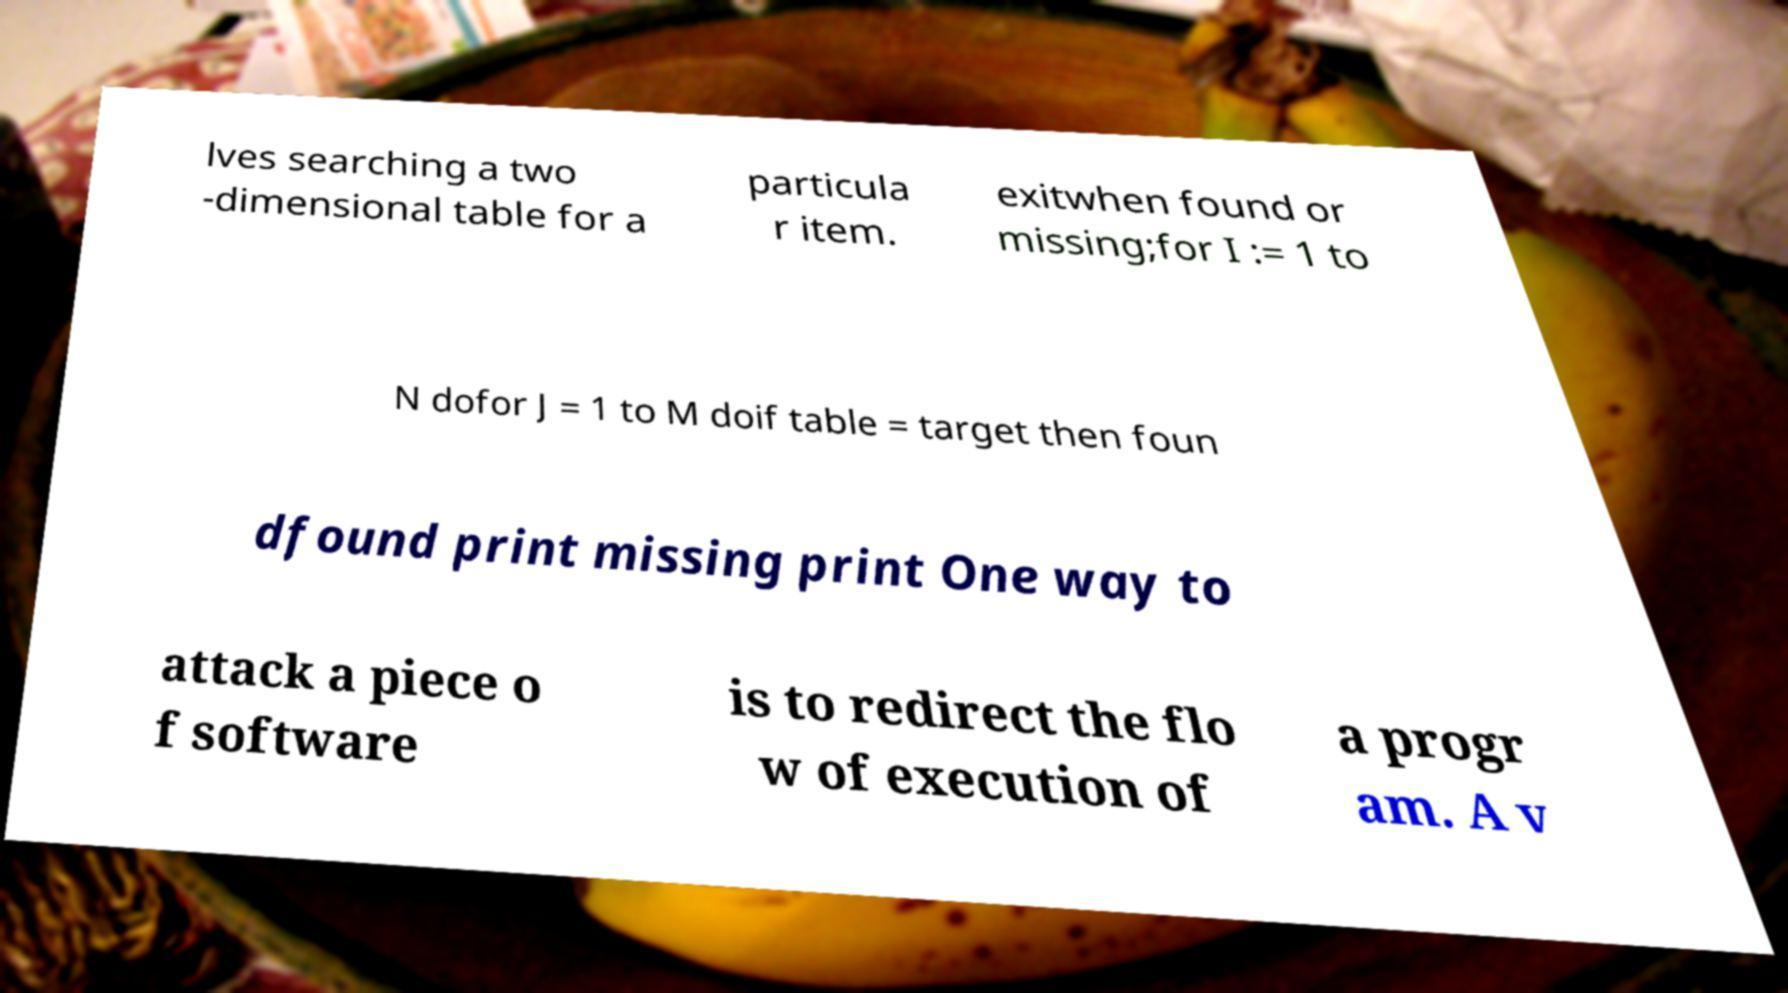Could you extract and type out the text from this image? lves searching a two -dimensional table for a particula r item. exitwhen found or missing;for I := 1 to N dofor J = 1 to M doif table = target then foun dfound print missing print One way to attack a piece o f software is to redirect the flo w of execution of a progr am. A v 